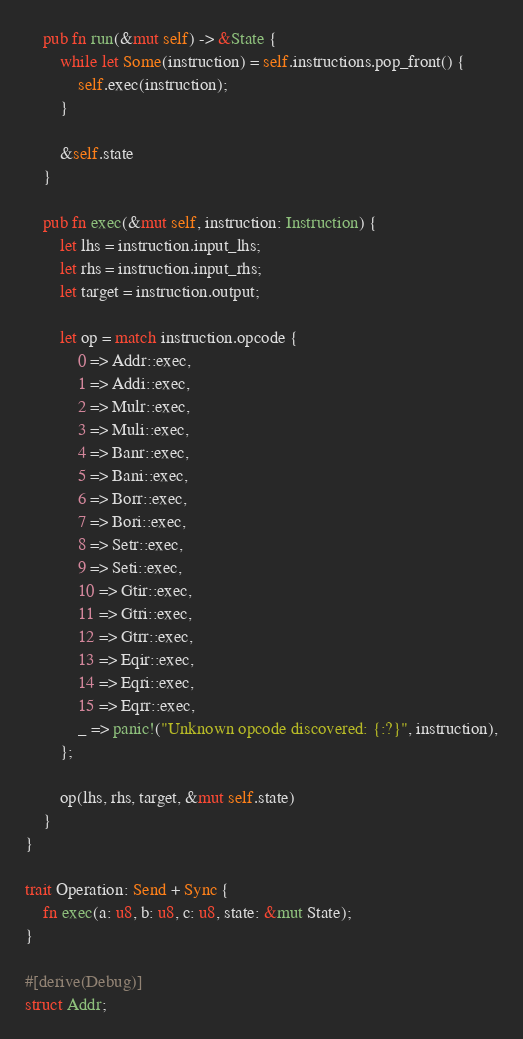Convert code to text. <code><loc_0><loc_0><loc_500><loc_500><_Rust_>    pub fn run(&mut self) -> &State {
        while let Some(instruction) = self.instructions.pop_front() {
            self.exec(instruction);
        }

        &self.state
    }

    pub fn exec(&mut self, instruction: Instruction) {
        let lhs = instruction.input_lhs;
        let rhs = instruction.input_rhs;
        let target = instruction.output;

        let op = match instruction.opcode {
            0 => Addr::exec,
            1 => Addi::exec,
            2 => Mulr::exec,
            3 => Muli::exec,
            4 => Banr::exec,
            5 => Bani::exec,
            6 => Borr::exec,
            7 => Bori::exec,
            8 => Setr::exec,
            9 => Seti::exec,
            10 => Gtir::exec,
            11 => Gtri::exec,
            12 => Gtrr::exec,
            13 => Eqir::exec,
            14 => Eqri::exec,
            15 => Eqrr::exec,
            _ => panic!("Unknown opcode discovered: {:?}", instruction),
        };

        op(lhs, rhs, target, &mut self.state)
    }
}

trait Operation: Send + Sync {
    fn exec(a: u8, b: u8, c: u8, state: &mut State);
}

#[derive(Debug)]
struct Addr;
</code> 